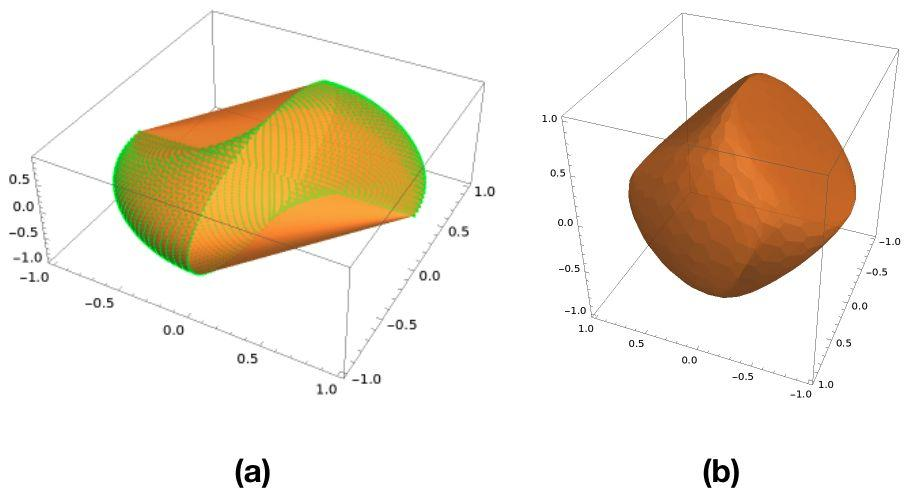Could you explain what might cause the different patterns observed in Figures (a) and (b)? Figure (a) demonstrates a sinusoidal pattern, which could indicate a mathematical function or model, such as a sine wave, applied to simulate or depict real-world phenomena like waves or vibrations. On the other hand, Figure (b) might represent a more homogenous material or condition, showing no variation, which could be indicative of an object under uniform conditions or a simplified model where external variations are not accounted for. 